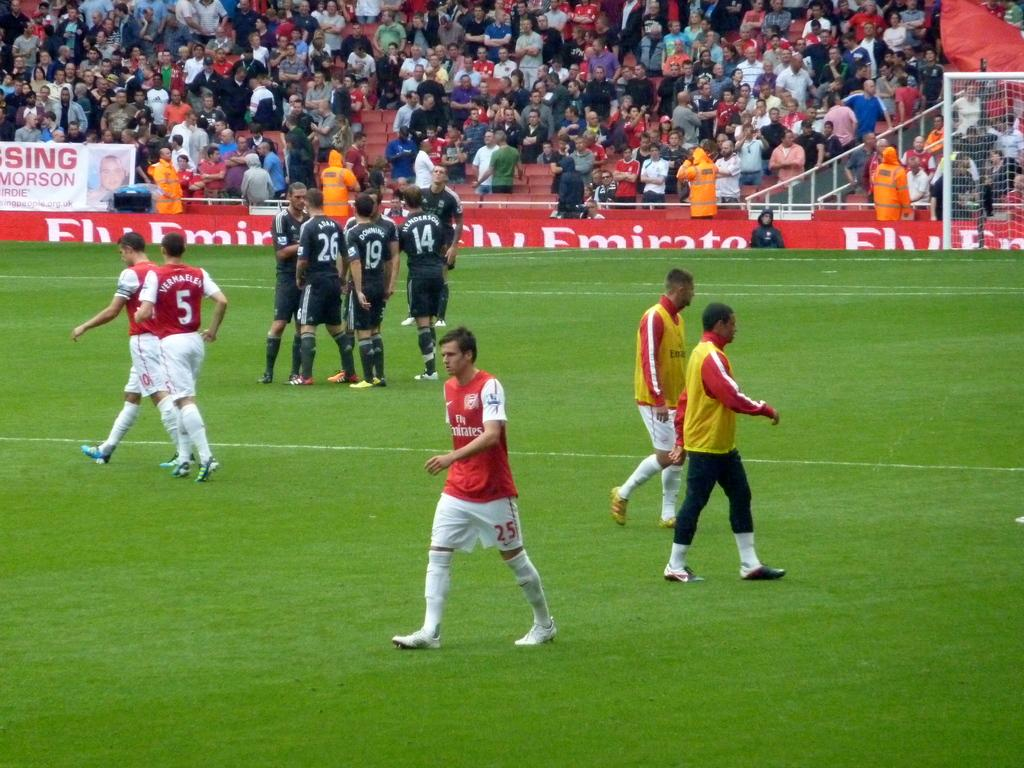<image>
Render a clear and concise summary of the photo. A soccer field advertisement encourages people to Fly Emirates. 